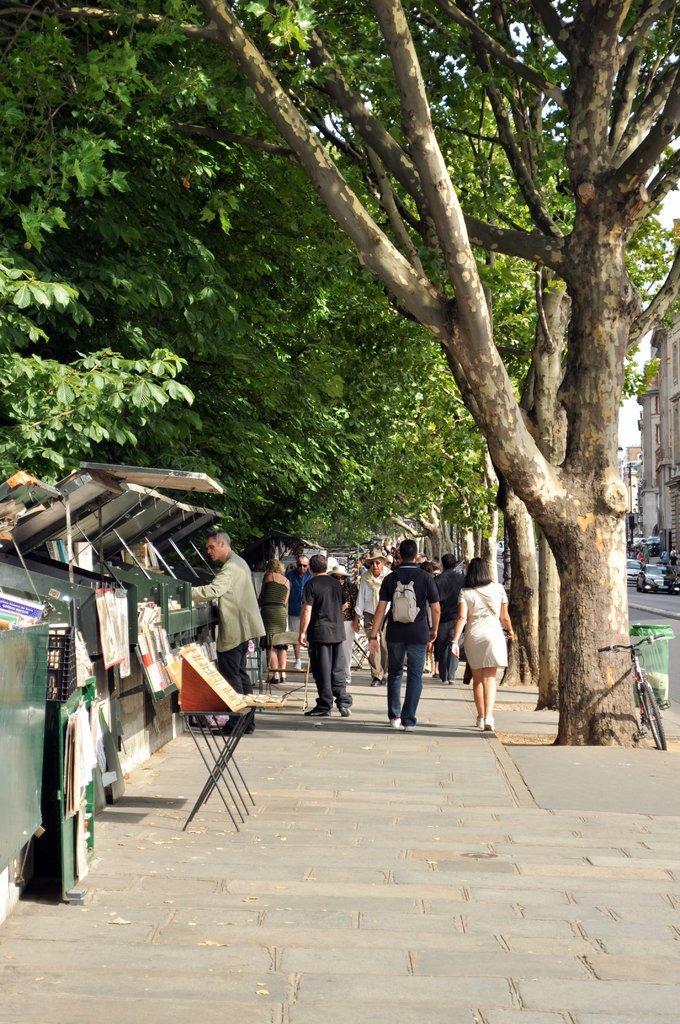How would you summarize this image in a sentence or two? In the picture I can see a few people walking on the side of the road. I can see the trees on the side of the road. There are buildings on the right side and vehicles on the road. 